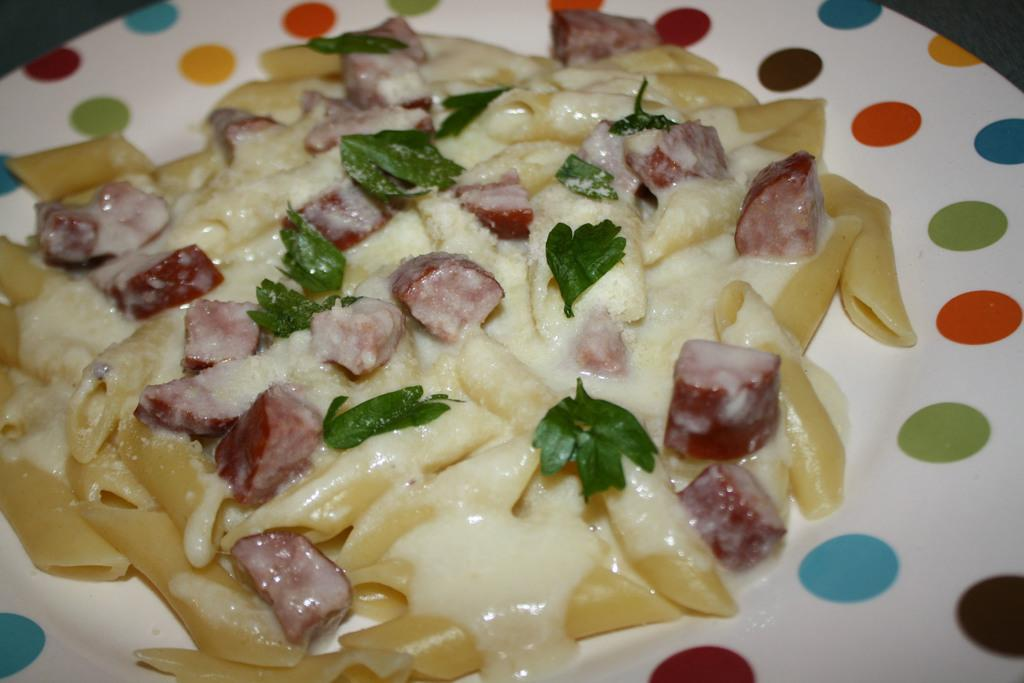What is on the plate in the image? There is food on a plate in the image. Can you describe the colors of the food on the plate? The food has colors including white, cream, red, and green. What type of mint is being used in the operation depicted in the image? There is no operation or mint present in the image; it only shows food on a plate. 